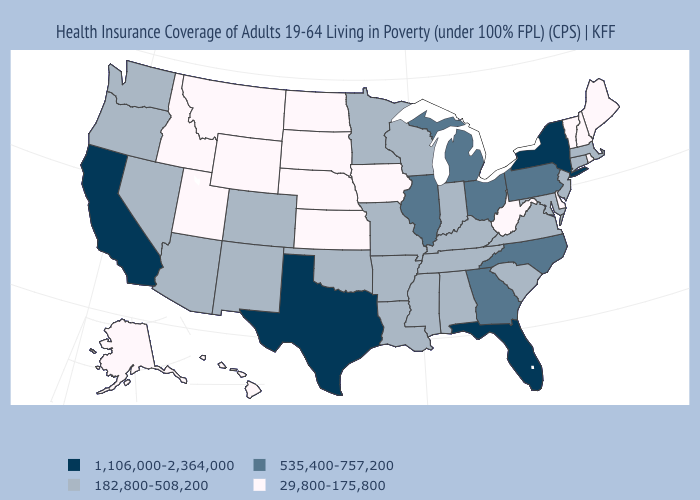Name the states that have a value in the range 29,800-175,800?
Short answer required. Alaska, Delaware, Hawaii, Idaho, Iowa, Kansas, Maine, Montana, Nebraska, New Hampshire, North Dakota, Rhode Island, South Dakota, Utah, Vermont, West Virginia, Wyoming. What is the value of Tennessee?
Keep it brief. 182,800-508,200. Is the legend a continuous bar?
Keep it brief. No. What is the lowest value in states that border North Carolina?
Keep it brief. 182,800-508,200. Does the map have missing data?
Answer briefly. No. Among the states that border Pennsylvania , does Ohio have the highest value?
Answer briefly. No. Is the legend a continuous bar?
Answer briefly. No. Name the states that have a value in the range 535,400-757,200?
Write a very short answer. Georgia, Illinois, Michigan, North Carolina, Ohio, Pennsylvania. Does North Carolina have the lowest value in the South?
Write a very short answer. No. What is the value of Nevada?
Give a very brief answer. 182,800-508,200. What is the lowest value in the USA?
Keep it brief. 29,800-175,800. Does Pennsylvania have the highest value in the Northeast?
Give a very brief answer. No. Which states have the highest value in the USA?
Quick response, please. California, Florida, New York, Texas. 